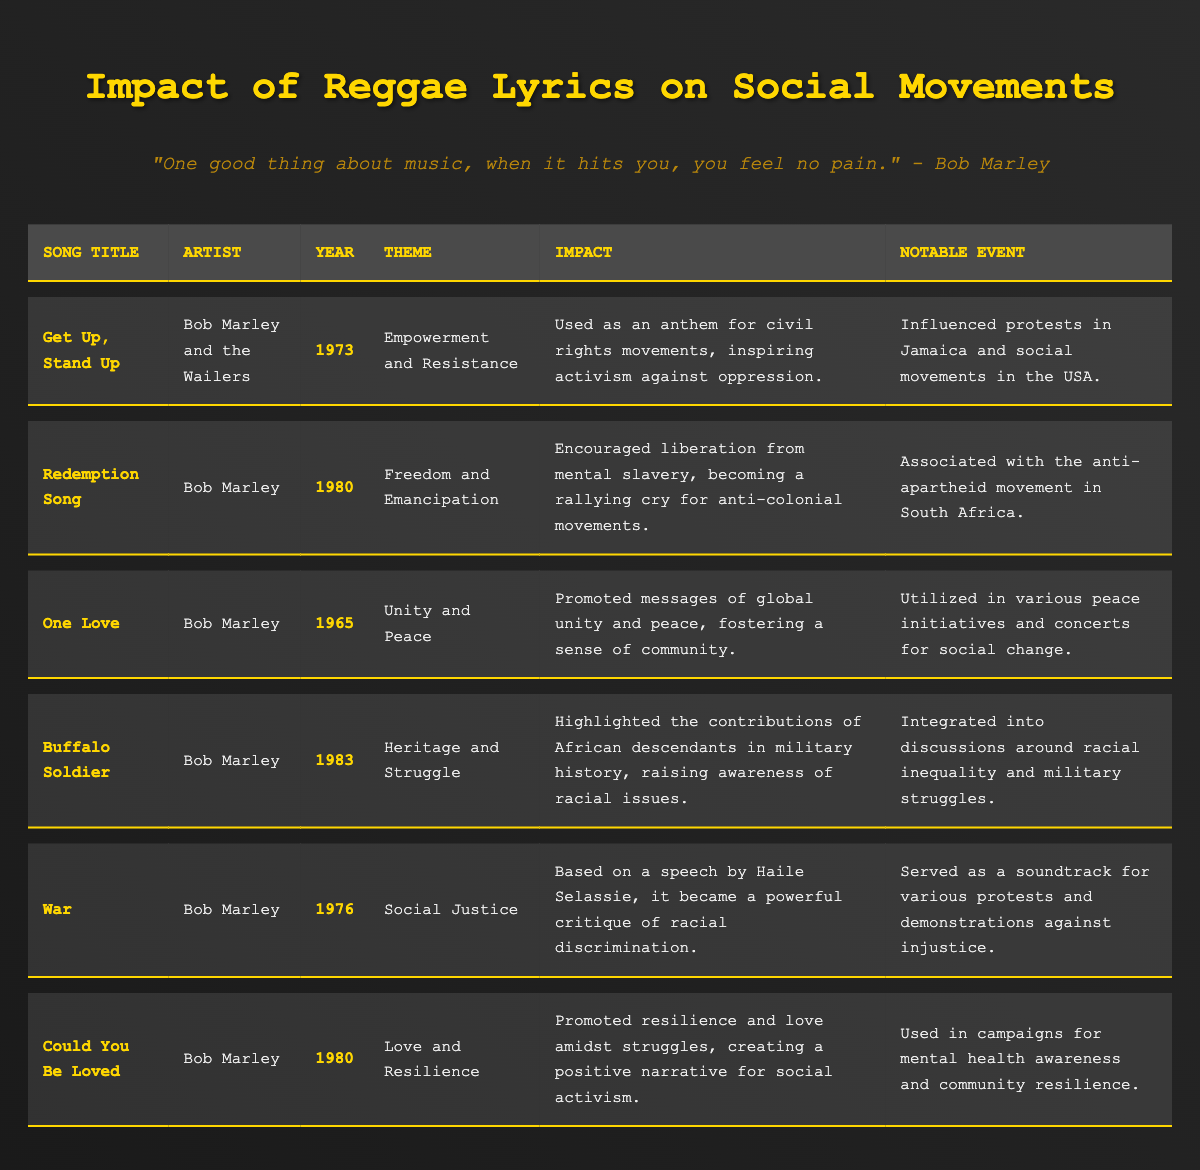What is the song title from 1973 that focuses on empowerment and resistance? The table lists the song titles along with their respective years and themes. For the year 1973, the song title is "Get Up, Stand Up," which focuses on empowerment and resistance.
Answer: Get Up, Stand Up Which artist performed the song "Redemption Song"? Looking at the table, the song "Redemption Song" is associated with the artist Bob Marley.
Answer: Bob Marley What notable event is linked with the song "War"? The table indicates that "War" served as a soundtrack for various protests and demonstrations against injustice, which is its notable event.
Answer: Protests against injustice Is "One Love" associated with the theme of unity and peace? By checking the table, "One Love" is indeed listed under the theme of unity and peace, confirming that the statement is true.
Answer: Yes Which song addresses the theme of heritage and struggle and was released in 1983? The table indicates that "Buffalo Soldier" addresses the theme of heritage and struggle and was released in the year 1983.
Answer: Buffalo Soldier How many songs in the table were released in the 1980s? The table shows two songs released in the 1980s: "Redemption Song" (1980) and "Could You Be Loved" (1980). Thus, there are 2 songs from the 1980s.
Answer: 2 What was the impact of "Get Up, Stand Up"? The table specifies that "Get Up, Stand Up" was used as an anthem for civil rights movements and inspired activism against oppression, highlighting its impact.
Answer: Anthem for civil rights Which song mentions mental slavery, and what year was it released? Looking through the table, "Redemption Song" mentions mental slavery and was released in 1980.
Answer: Redemption Song, 1980 Which song has the most recent release year? From the table, the most recent song is "Buffalo Soldier," released in 1983.
Answer: Buffalo Soldier What is the primary theme of “Could You Be Loved”? Referencing the table, the primary theme of "Could You Be Loved" is love and resilience.
Answer: Love and Resilience What impact did "One Love" have in social initiatives? The table states that "One Love" was utilized in various peace initiatives and concerts for social change, indicating its significant impact.
Answer: Peace initiatives and concerts Which song served as a rallying cry for anti-colonial movements? According to the table, "Redemption Song" became a rallying cry for anti-colonial movements, confirming its significant role.
Answer: Redemption Song Does "War" address racial discrimination? The table indicates that "War," based on a speech by Haile Selassie, critiques racial discrimination, confirming that the statement is true.
Answer: Yes What common theme is shared by both "One Love" and "Get Up, Stand Up"? Examining the table, both songs promote the concepts of unity and empowerment, respectively, but they share a broader theme of social justice and activism.
Answer: Social justice and activism In which song is the theme of love amidst struggles promoted? The table clearly states that "Could You Be Loved" promotes love amidst struggles, indicating its thematic focus.
Answer: Could You Be Loved Identify the song that highlighted contributions of African descendants in military history. The table specifies "Buffalo Soldier" as the song that highlights the contributions of African descendants in military history.
Answer: Buffalo Soldier 